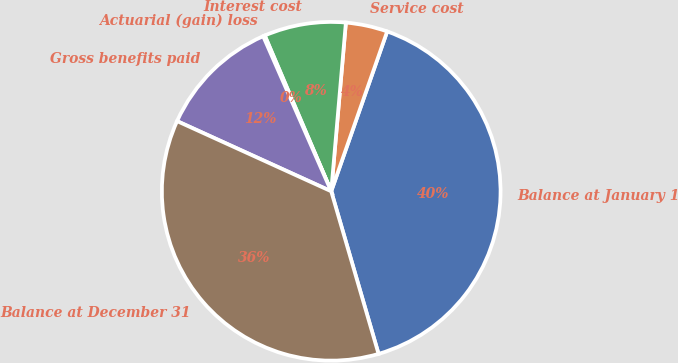<chart> <loc_0><loc_0><loc_500><loc_500><pie_chart><fcel>Balance at January 1<fcel>Service cost<fcel>Interest cost<fcel>Actuarial (gain) loss<fcel>Gross benefits paid<fcel>Balance at December 31<nl><fcel>40.13%<fcel>3.98%<fcel>7.8%<fcel>0.16%<fcel>11.62%<fcel>36.31%<nl></chart> 